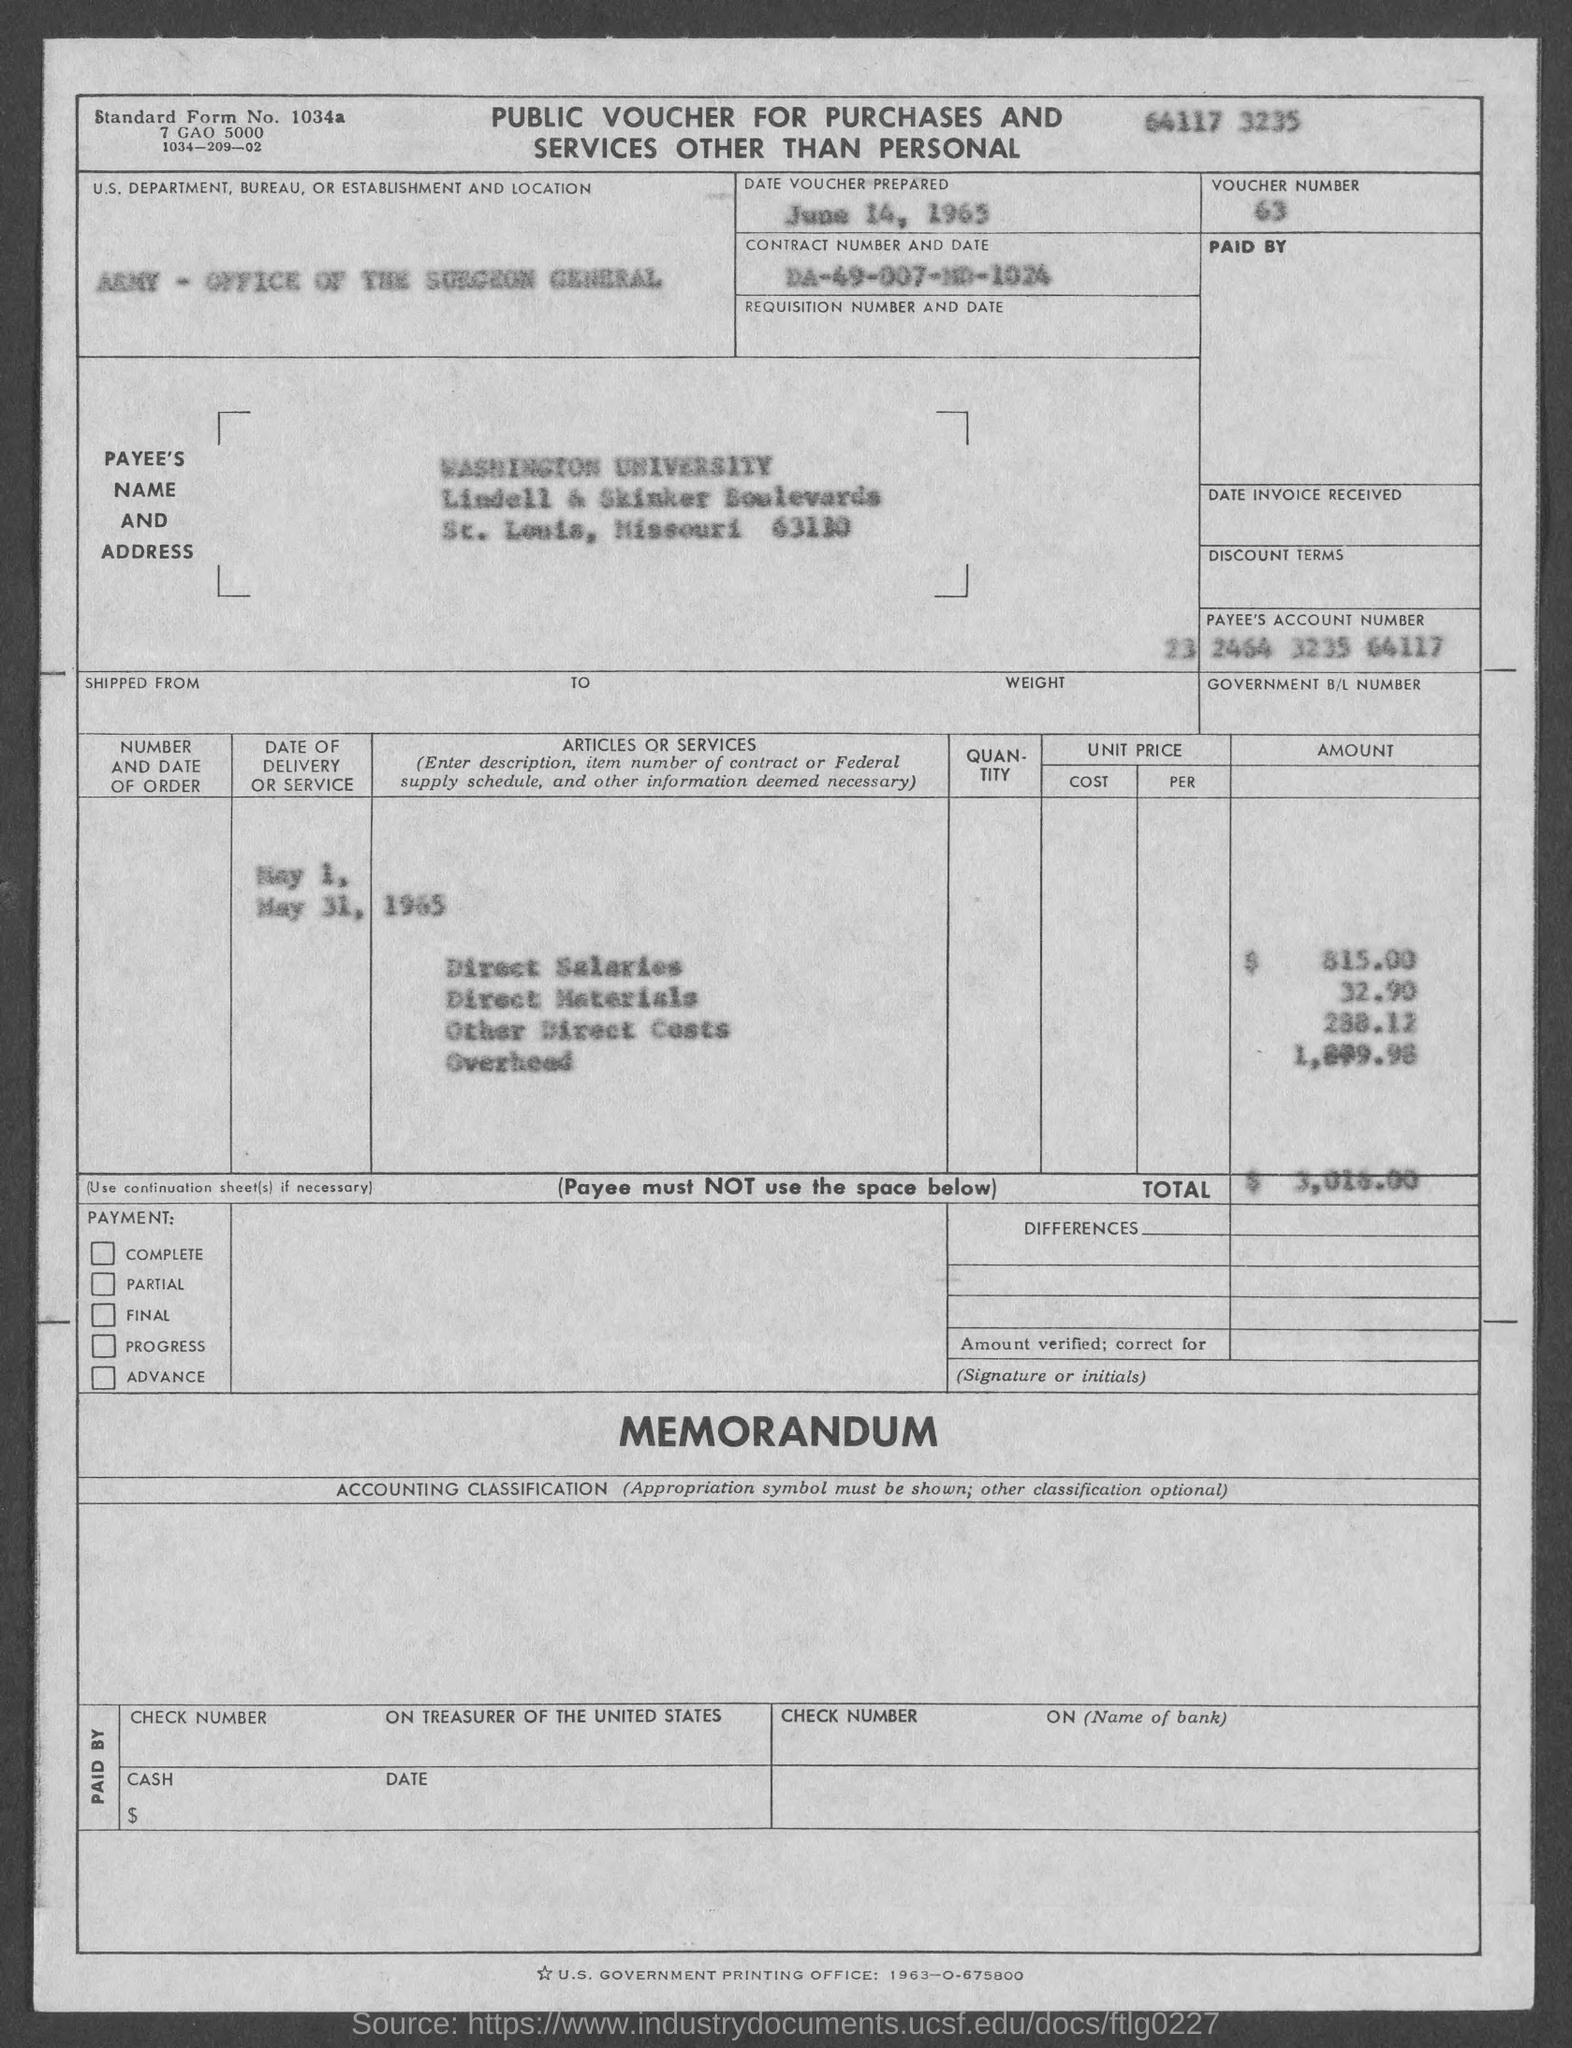What is the voucher no.?
Give a very brief answer. 63. What is the standard form no.?
Offer a very short reply. 1034a. When is the date voucher prepared ?
Provide a succinct answer. June 14, 1965. What is the us. department, bureau, or establishment in voucher?
Keep it short and to the point. Army - Office of the Surgeon General. 